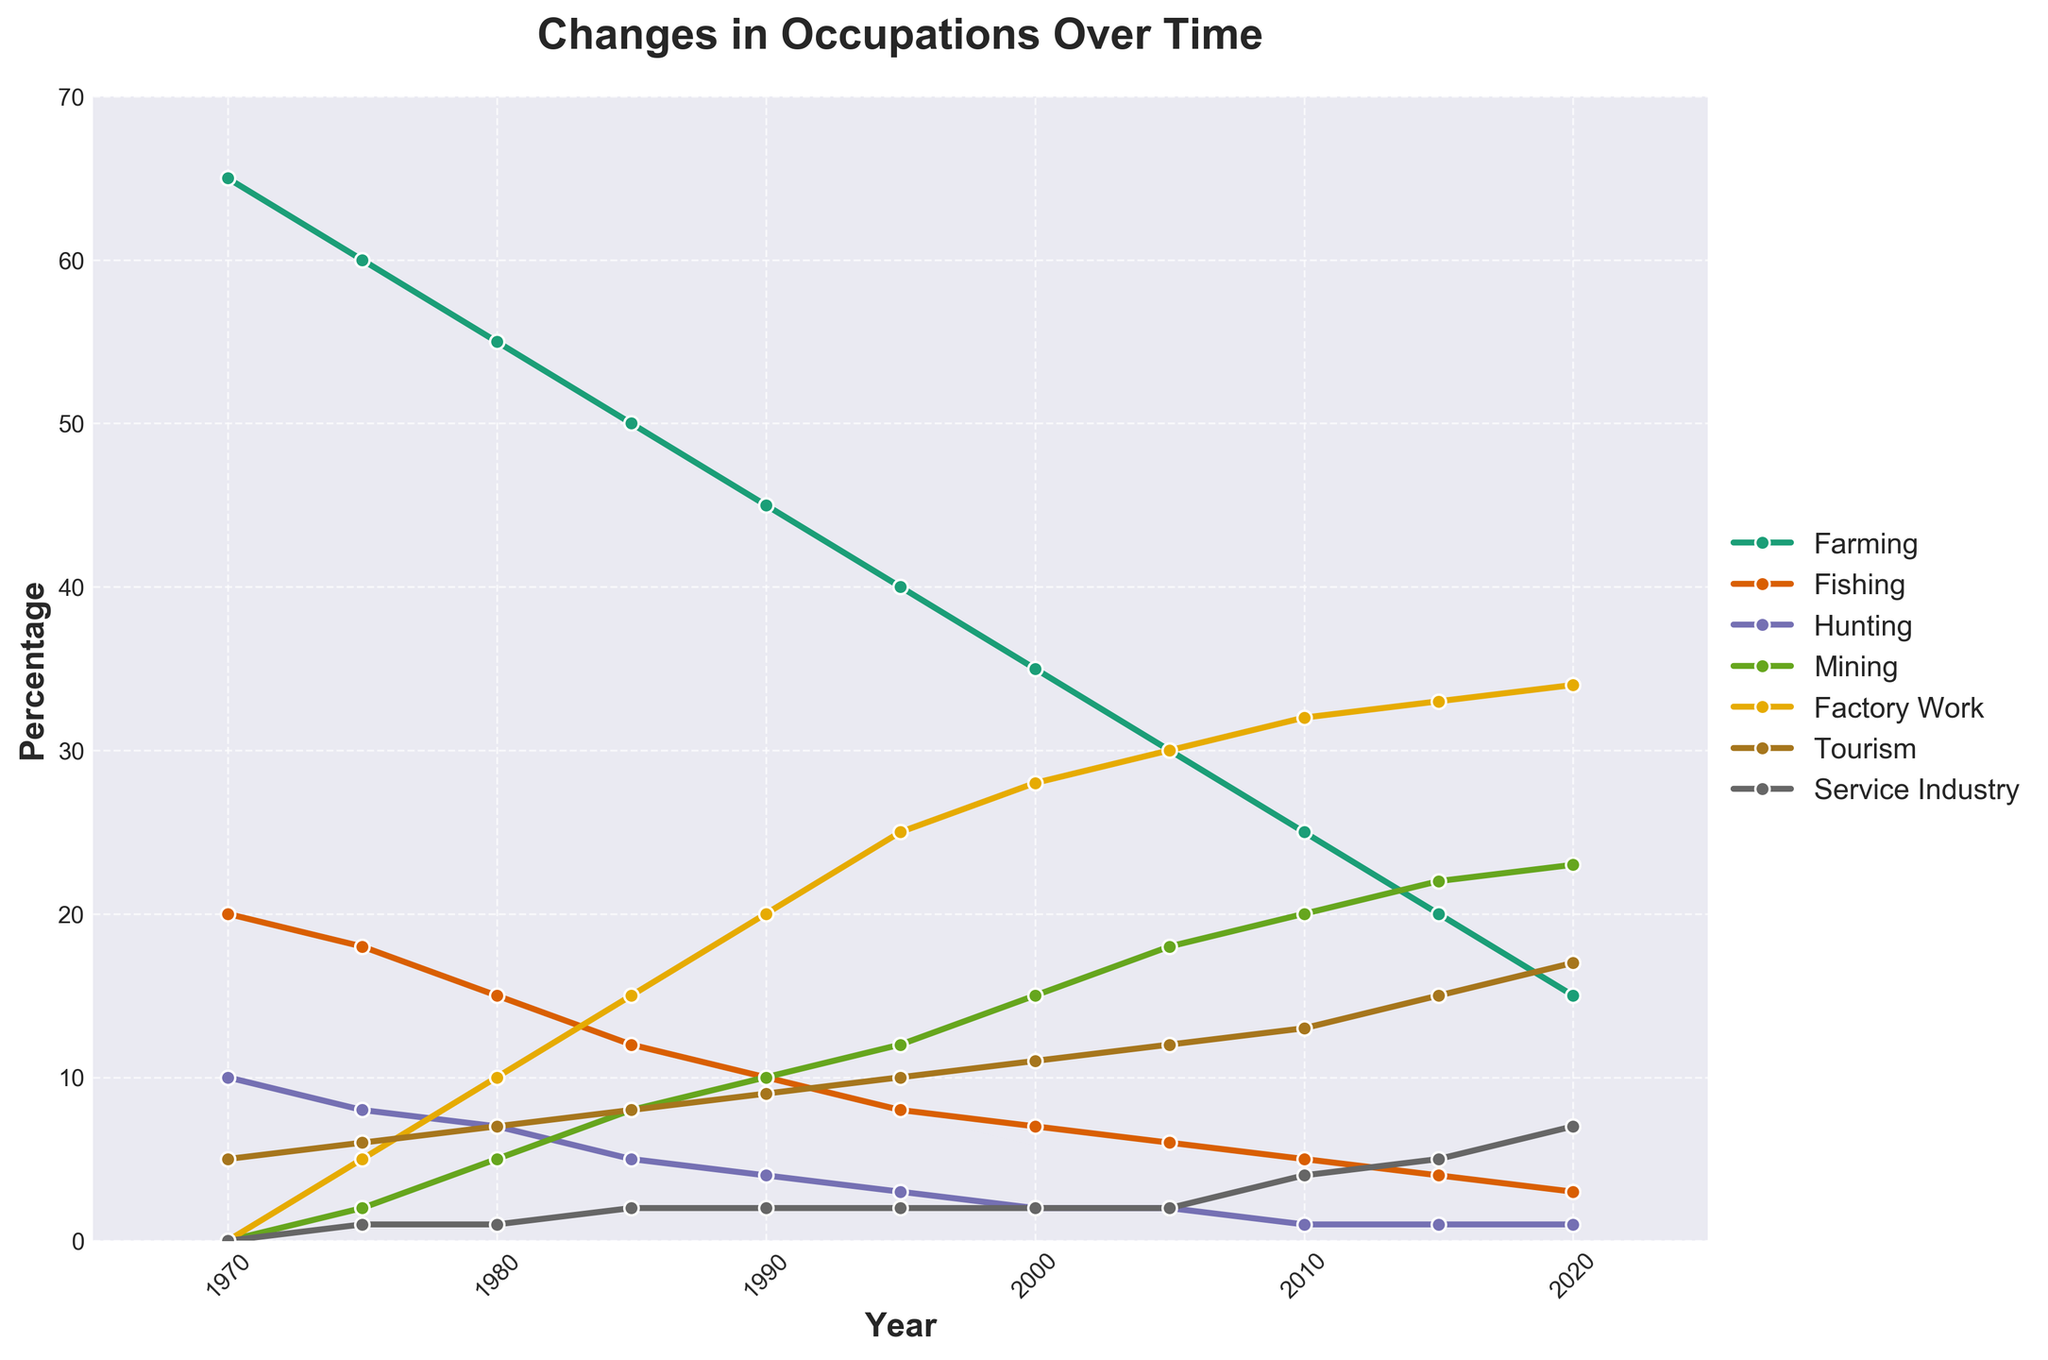Which occupation had the highest percentage in 1970? Look at the data corresponding to the year 1970. Farming has the highest percentage of 65 in that year.
Answer: Farming Which year had the highest percentage for factory work? Look at the line representing factory work in the chart. The peak in the factory work line is in 2020 at 34%.
Answer: 2020 What is the difference in the percentage of farming between 1970 and 2020? Subtract the percentage of farming in 2020 from the percentage in 1970 (65 - 15 = 50).
Answer: 50 Which two modern occupations showed a consistent increase over the time span? Look at the lines representing tourism and service industry. Both show a continuous upward trend.
Answer: Tourism, Service Industry In which year did the percentage of mining surpass hunting? Find the point where the mining line goes above the hunting line. This happens between 1975 and 1980. Specifically, in 1980, mining (5%) surpasses hunting (4%).
Answer: 1980 Compare the percentage of fishing and tourism in 1995. Which one is higher? Refer to the data for 1995. Fishing is at 8%, and tourism is at 10%.
Answer: Tourism What is the average percentage of the service industry occupation from 1970 to 2020? Sum the percentages of the service industry for all the years and then divide by the number of years (0 + 1 + 1 + 2 + 2 + 2 + 2 + 2 + 4 + 5 + 7 = 28; 28 / 11 = 2.55).
Answer: 2.55 Which year shows the highest combined percentage of traditional occupations (farming, fishing, and hunting)? Add the percentages of farming, fishing, and hunting for each year and compare. 1970 has the highest combined percentage:
65 + 20 + 10 = 95.
Answer: 1970 Between 1980 and 1990, which modern occupation showed the greatest increase? Compare the values for mining, factory work, tourism, and service industry between 1980 and 1990. Factory work jumped from 10% to 20%, a 10% increase.
Answer: Factory Work 